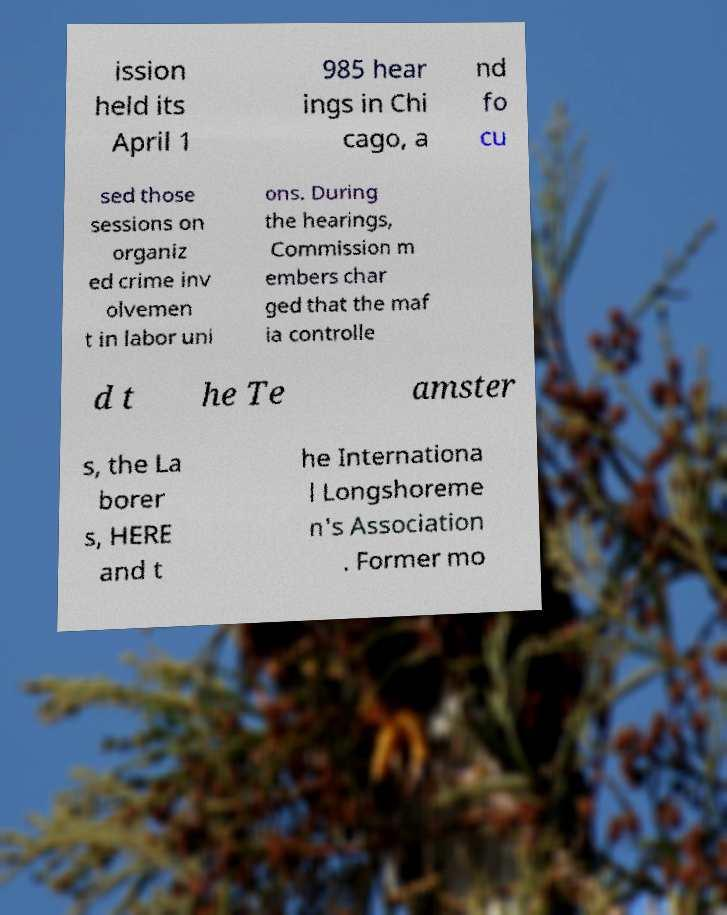Could you extract and type out the text from this image? ission held its April 1 985 hear ings in Chi cago, a nd fo cu sed those sessions on organiz ed crime inv olvemen t in labor uni ons. During the hearings, Commission m embers char ged that the maf ia controlle d t he Te amster s, the La borer s, HERE and t he Internationa l Longshoreme n's Association . Former mo 